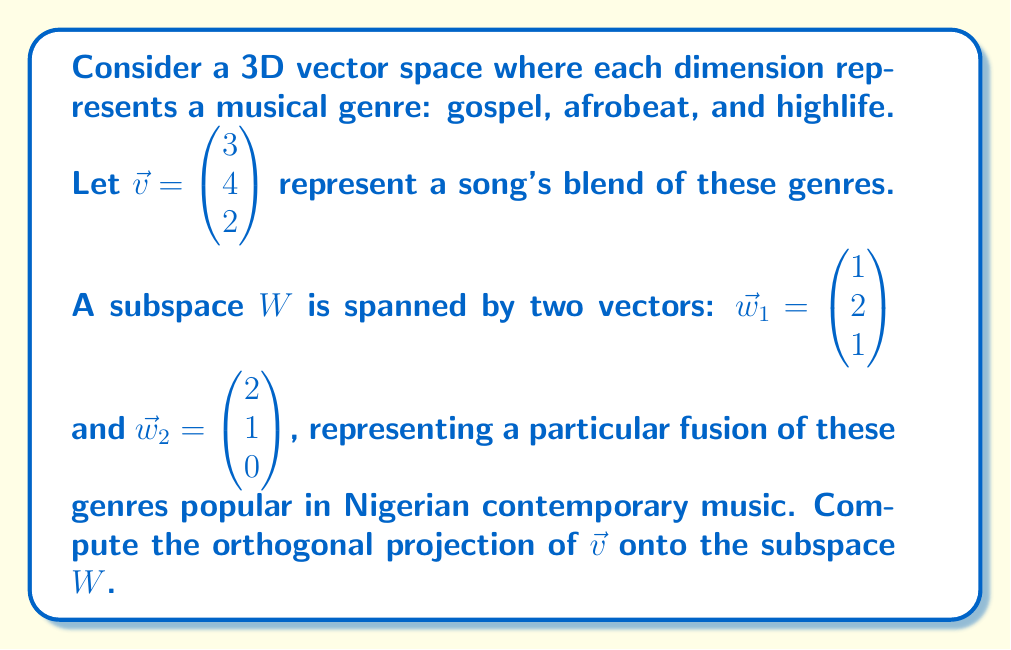Provide a solution to this math problem. To find the orthogonal projection of $\vec{v}$ onto the subspace $W$, we'll follow these steps:

1) First, we need to find an orthonormal basis for $W$. We'll use the Gram-Schmidt process on $\vec{w}_1$ and $\vec{w}_2$.

   Let $\vec{u}_1 = \vec{w}_1 = \begin{pmatrix} 1 \\ 2 \\ 1 \end{pmatrix}$

   $\vec{u}_2 = \vec{w}_2 - \text{proj}_{\vec{u}_1}(\vec{w}_2)$
   
   $= \begin{pmatrix} 2 \\ 1 \\ 0 \end{pmatrix} - \frac{\vec{w}_2 \cdot \vec{u}_1}{\|\vec{u}_1\|^2}\vec{u}_1$
   
   $= \begin{pmatrix} 2 \\ 1 \\ 0 \end{pmatrix} - \frac{4+2+0}{1^2+2^2+1^2}\begin{pmatrix} 1 \\ 2 \\ 1 \end{pmatrix}$
   
   $= \begin{pmatrix} 2 \\ 1 \\ 0 \end{pmatrix} - \frac{6}{6}\begin{pmatrix} 1 \\ 2 \\ 1 \end{pmatrix} = \begin{pmatrix} 1 \\ -1 \\ -1 \end{pmatrix}$

2) Now we normalize these vectors:

   $\vec{e}_1 = \frac{\vec{u}_1}{\|\vec{u}_1\|} = \frac{1}{\sqrt{6}}\begin{pmatrix} 1 \\ 2 \\ 1 \end{pmatrix}$
   
   $\vec{e}_2 = \frac{\vec{u}_2}{\|\vec{u}_2\|} = \frac{1}{\sqrt{3}}\begin{pmatrix} 1 \\ -1 \\ -1 \end{pmatrix}$

3) The orthogonal projection of $\vec{v}$ onto $W$ is given by:

   $\text{proj}_W(\vec{v}) = (\vec{v} \cdot \vec{e}_1)\vec{e}_1 + (\vec{v} \cdot \vec{e}_2)\vec{e}_2$

4) Let's calculate each dot product:

   $\vec{v} \cdot \vec{e}_1 = \frac{1}{\sqrt{6}}(3 + 8 + 2) = \frac{13}{\sqrt{6}}$
   
   $\vec{v} \cdot \vec{e}_2 = \frac{1}{\sqrt{3}}(3 - 4 - 2) = -\frac{3}{\sqrt{3}}$

5) Now we can compute the projection:

   $\text{proj}_W(\vec{v}) = \frac{13}{\sqrt{6}} \cdot \frac{1}{\sqrt{6}}\begin{pmatrix} 1 \\ 2 \\ 1 \end{pmatrix} + (-\frac{3}{\sqrt{3}}) \cdot \frac{1}{\sqrt{3}}\begin{pmatrix} 1 \\ -1 \\ -1 \end{pmatrix}$
   
   $= \frac{13}{6}\begin{pmatrix} 1 \\ 2 \\ 1 \end{pmatrix} - \begin{pmatrix} 1 \\ -1 \\ -1 \end{pmatrix}$
   
   $= \begin{pmatrix} 13/6 - 1 \\ 13/3 + 1 \\ 13/6 + 1 \end{pmatrix}$
Answer: The orthogonal projection of $\vec{v}$ onto the subspace $W$ is:

$$\text{proj}_W(\vec{v}) = \begin{pmatrix} 7/6 \\ 16/3 \\ 19/6 \end{pmatrix}$$ 